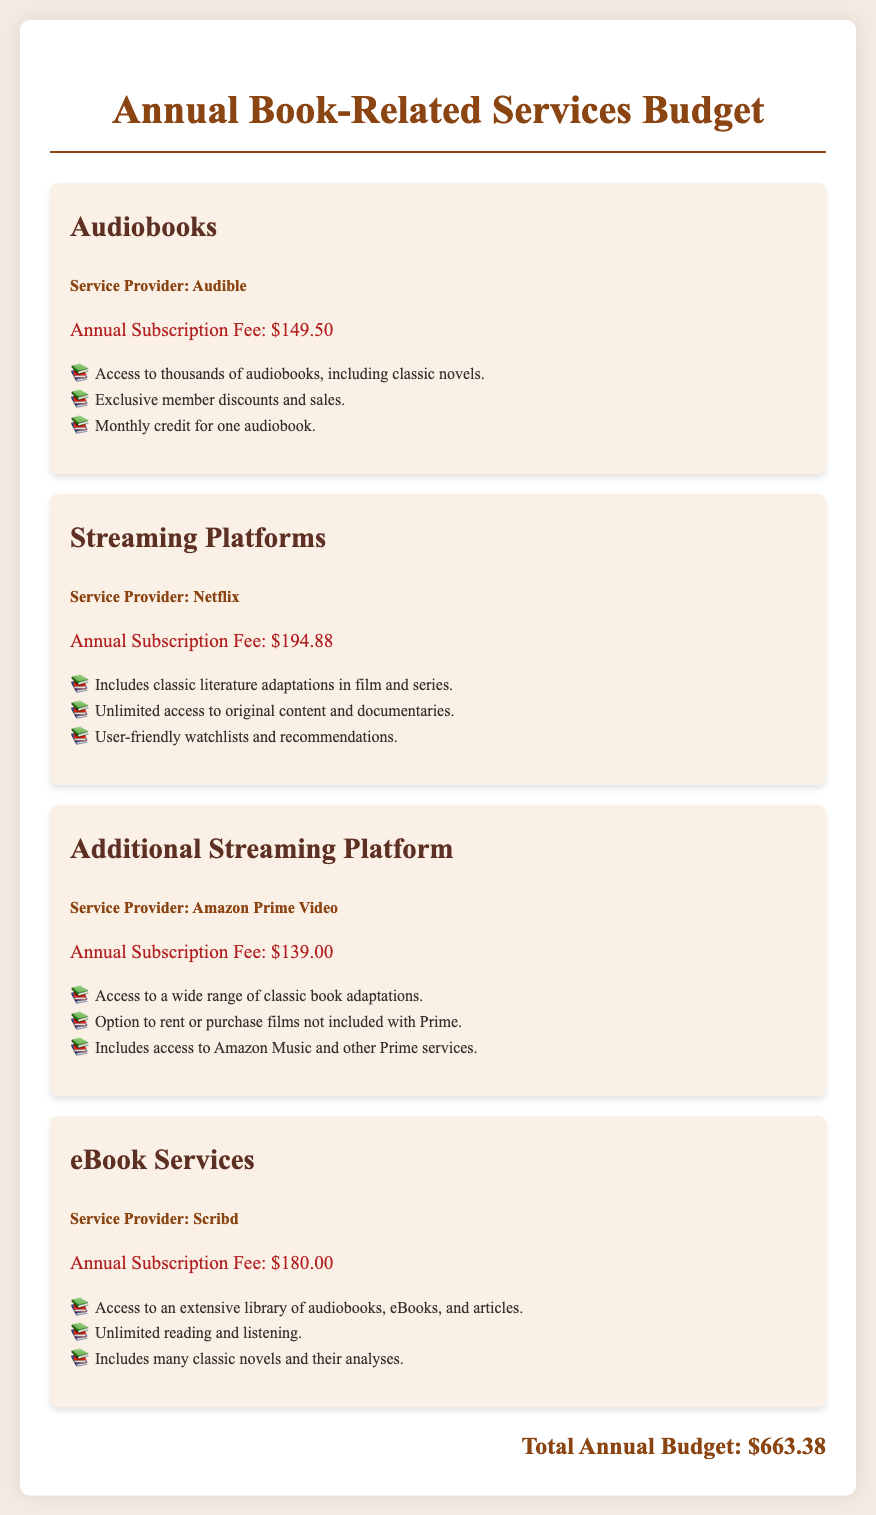What is the annual subscription fee for Audible? The annual subscription fee for Audible is clearly stated in the document.
Answer: $149.50 How much does Netflix charge annually? The document provides the annual subscription fee for Netflix.
Answer: $194.88 Which service offers unlimited reading and listening? The document details a service that emphasizes unlimited reading and listening.
Answer: Scribd What is the total annual budget for book-related services? The document sums up the annual fees for all book-related services to provide a total.
Answer: $663.38 How many classic book adaptations does Amazon Prime Video offer? The document indicates that Amazon Prime Video provides access to a wide range of classic adaptations without specifying a number, but it mentions "a wide range."
Answer: A wide range Which service provider offers audiobooks, eBooks, and articles? The document specifically lists a service provider that includes these options.
Answer: Scribd Which service is mentioned first in the document? The order of the services listed in the document reveals which one is presented first.
Answer: Audible Are exclusive member discounts available with Audible? The document contains information about member benefits for Audible, including discounts.
Answer: Yes 